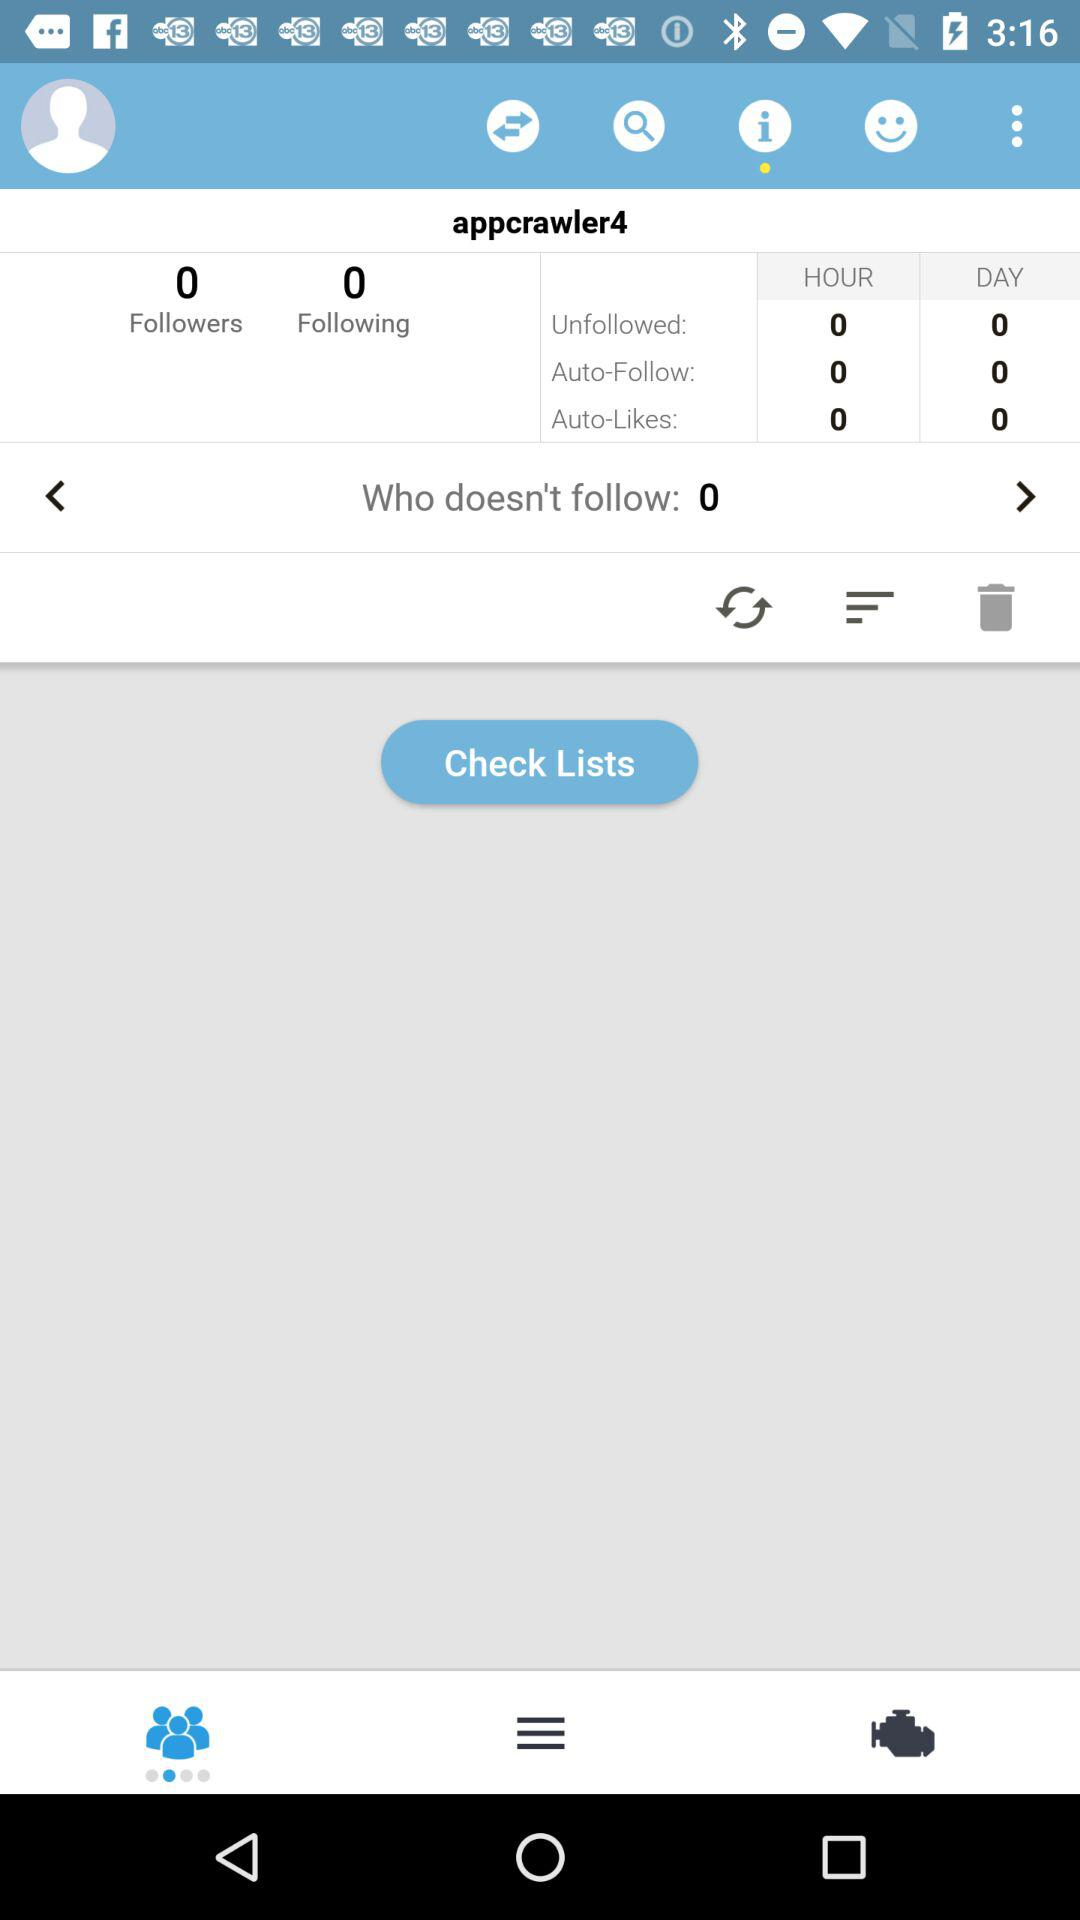How many followers are there? There are 0 followers. 